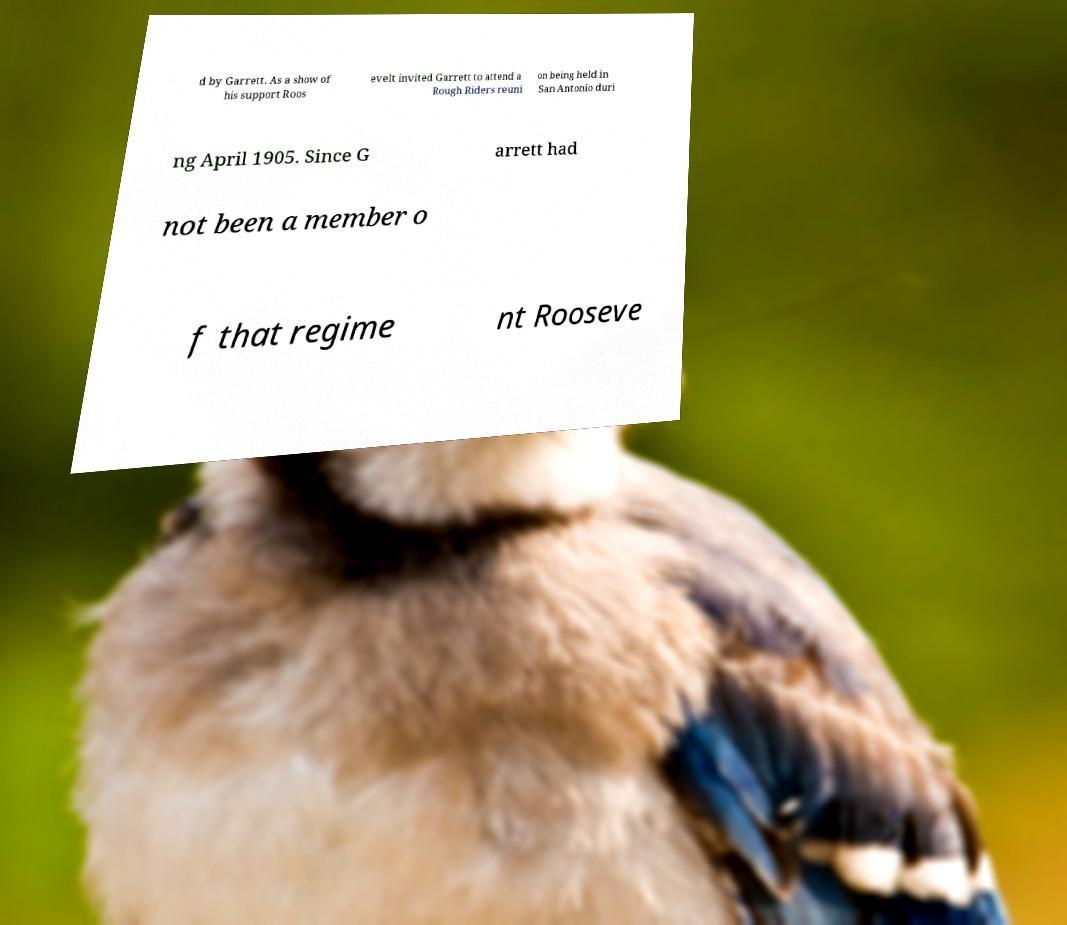I need the written content from this picture converted into text. Can you do that? d by Garrett. As a show of his support Roos evelt invited Garrett to attend a Rough Riders reuni on being held in San Antonio duri ng April 1905. Since G arrett had not been a member o f that regime nt Rooseve 